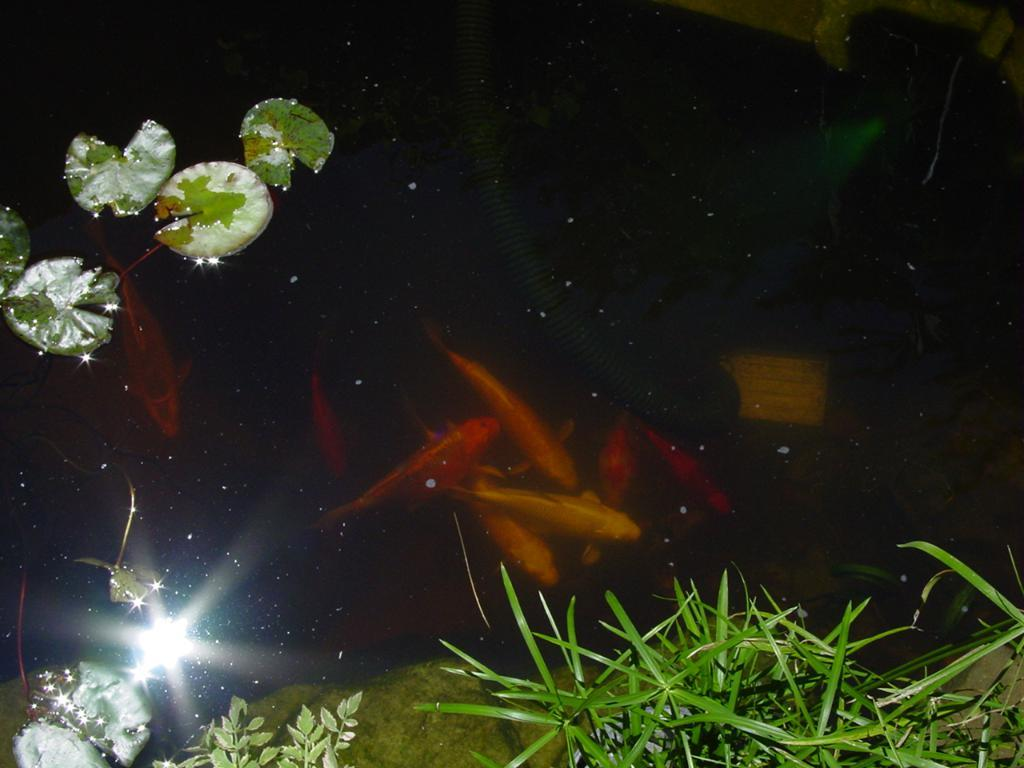What color are the fishes in the image? The fishes in the image are orange. Where are the fishes located? The fishes are in a pound. What is covering the water in the image? There is grass and leaves on the water in the image. How does the beginner fish learn to swim in the image? There is no indication in the image that there is a beginner fish, nor does the image show any learning process. 